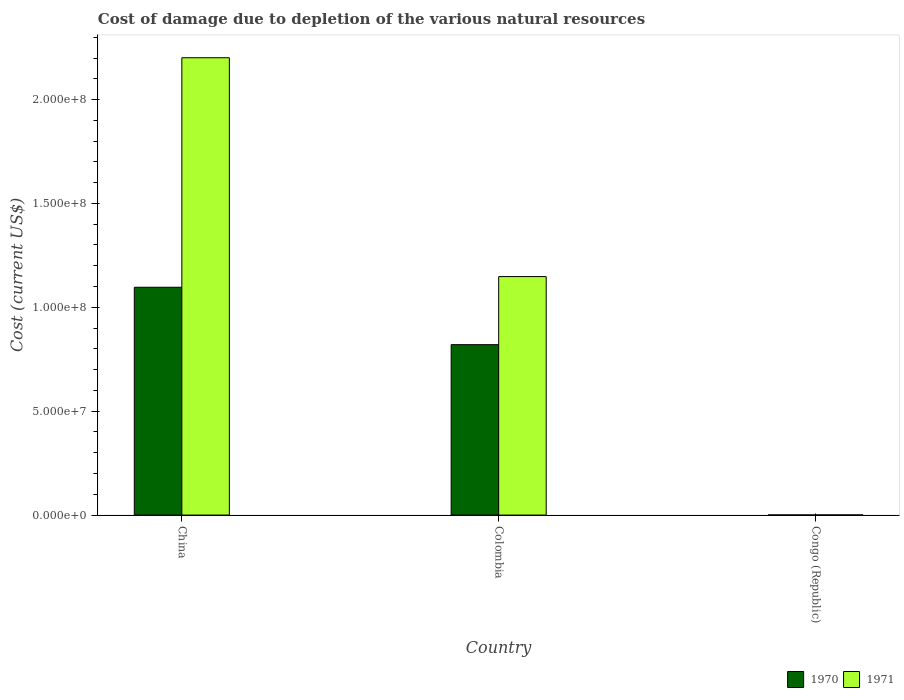How many different coloured bars are there?
Your answer should be very brief. 2. How many groups of bars are there?
Make the answer very short. 3. Are the number of bars on each tick of the X-axis equal?
Your answer should be very brief. Yes. What is the label of the 2nd group of bars from the left?
Ensure brevity in your answer.  Colombia. In how many cases, is the number of bars for a given country not equal to the number of legend labels?
Ensure brevity in your answer.  0. What is the cost of damage caused due to the depletion of various natural resources in 1970 in Congo (Republic)?
Your answer should be very brief. 6.34e+04. Across all countries, what is the maximum cost of damage caused due to the depletion of various natural resources in 1970?
Make the answer very short. 1.10e+08. Across all countries, what is the minimum cost of damage caused due to the depletion of various natural resources in 1970?
Your answer should be very brief. 6.34e+04. In which country was the cost of damage caused due to the depletion of various natural resources in 1971 maximum?
Provide a succinct answer. China. In which country was the cost of damage caused due to the depletion of various natural resources in 1970 minimum?
Provide a short and direct response. Congo (Republic). What is the total cost of damage caused due to the depletion of various natural resources in 1970 in the graph?
Your response must be concise. 1.92e+08. What is the difference between the cost of damage caused due to the depletion of various natural resources in 1970 in Colombia and that in Congo (Republic)?
Give a very brief answer. 8.20e+07. What is the difference between the cost of damage caused due to the depletion of various natural resources in 1971 in Congo (Republic) and the cost of damage caused due to the depletion of various natural resources in 1970 in Colombia?
Offer a very short reply. -8.19e+07. What is the average cost of damage caused due to the depletion of various natural resources in 1970 per country?
Offer a terse response. 6.39e+07. What is the difference between the cost of damage caused due to the depletion of various natural resources of/in 1971 and cost of damage caused due to the depletion of various natural resources of/in 1970 in Congo (Republic)?
Provide a succinct answer. 1.00e+04. What is the ratio of the cost of damage caused due to the depletion of various natural resources in 1970 in China to that in Colombia?
Make the answer very short. 1.34. Is the cost of damage caused due to the depletion of various natural resources in 1971 in Colombia less than that in Congo (Republic)?
Keep it short and to the point. No. What is the difference between the highest and the second highest cost of damage caused due to the depletion of various natural resources in 1970?
Your response must be concise. -1.10e+08. What is the difference between the highest and the lowest cost of damage caused due to the depletion of various natural resources in 1971?
Keep it short and to the point. 2.20e+08. What does the 1st bar from the left in China represents?
Your response must be concise. 1970. How many bars are there?
Ensure brevity in your answer.  6. Are all the bars in the graph horizontal?
Provide a succinct answer. No. How many countries are there in the graph?
Provide a succinct answer. 3. Are the values on the major ticks of Y-axis written in scientific E-notation?
Your answer should be compact. Yes. Where does the legend appear in the graph?
Offer a terse response. Bottom right. What is the title of the graph?
Your answer should be compact. Cost of damage due to depletion of the various natural resources. Does "1972" appear as one of the legend labels in the graph?
Make the answer very short. No. What is the label or title of the Y-axis?
Provide a short and direct response. Cost (current US$). What is the Cost (current US$) of 1970 in China?
Offer a terse response. 1.10e+08. What is the Cost (current US$) of 1971 in China?
Provide a short and direct response. 2.20e+08. What is the Cost (current US$) in 1970 in Colombia?
Your response must be concise. 8.20e+07. What is the Cost (current US$) in 1971 in Colombia?
Offer a very short reply. 1.15e+08. What is the Cost (current US$) in 1970 in Congo (Republic)?
Provide a short and direct response. 6.34e+04. What is the Cost (current US$) in 1971 in Congo (Republic)?
Keep it short and to the point. 7.34e+04. Across all countries, what is the maximum Cost (current US$) of 1970?
Offer a terse response. 1.10e+08. Across all countries, what is the maximum Cost (current US$) in 1971?
Your answer should be very brief. 2.20e+08. Across all countries, what is the minimum Cost (current US$) of 1970?
Provide a short and direct response. 6.34e+04. Across all countries, what is the minimum Cost (current US$) in 1971?
Ensure brevity in your answer.  7.34e+04. What is the total Cost (current US$) of 1970 in the graph?
Provide a succinct answer. 1.92e+08. What is the total Cost (current US$) in 1971 in the graph?
Your answer should be very brief. 3.35e+08. What is the difference between the Cost (current US$) in 1970 in China and that in Colombia?
Your response must be concise. 2.76e+07. What is the difference between the Cost (current US$) in 1971 in China and that in Colombia?
Your answer should be very brief. 1.05e+08. What is the difference between the Cost (current US$) of 1970 in China and that in Congo (Republic)?
Your answer should be very brief. 1.10e+08. What is the difference between the Cost (current US$) in 1971 in China and that in Congo (Republic)?
Make the answer very short. 2.20e+08. What is the difference between the Cost (current US$) in 1970 in Colombia and that in Congo (Republic)?
Make the answer very short. 8.20e+07. What is the difference between the Cost (current US$) in 1971 in Colombia and that in Congo (Republic)?
Offer a very short reply. 1.15e+08. What is the difference between the Cost (current US$) of 1970 in China and the Cost (current US$) of 1971 in Colombia?
Provide a short and direct response. -5.13e+06. What is the difference between the Cost (current US$) in 1970 in China and the Cost (current US$) in 1971 in Congo (Republic)?
Your answer should be very brief. 1.10e+08. What is the difference between the Cost (current US$) in 1970 in Colombia and the Cost (current US$) in 1971 in Congo (Republic)?
Provide a short and direct response. 8.19e+07. What is the average Cost (current US$) of 1970 per country?
Ensure brevity in your answer.  6.39e+07. What is the average Cost (current US$) in 1971 per country?
Your answer should be compact. 1.12e+08. What is the difference between the Cost (current US$) in 1970 and Cost (current US$) in 1971 in China?
Offer a terse response. -1.10e+08. What is the difference between the Cost (current US$) of 1970 and Cost (current US$) of 1971 in Colombia?
Your answer should be very brief. -3.28e+07. What is the difference between the Cost (current US$) in 1970 and Cost (current US$) in 1971 in Congo (Republic)?
Your answer should be very brief. -1.00e+04. What is the ratio of the Cost (current US$) of 1970 in China to that in Colombia?
Ensure brevity in your answer.  1.34. What is the ratio of the Cost (current US$) of 1971 in China to that in Colombia?
Your answer should be very brief. 1.92. What is the ratio of the Cost (current US$) of 1970 in China to that in Congo (Republic)?
Give a very brief answer. 1728.88. What is the ratio of the Cost (current US$) of 1971 in China to that in Congo (Republic)?
Ensure brevity in your answer.  2997.27. What is the ratio of the Cost (current US$) of 1970 in Colombia to that in Congo (Republic)?
Your answer should be compact. 1293.18. What is the ratio of the Cost (current US$) in 1971 in Colombia to that in Congo (Republic)?
Offer a terse response. 1562.98. What is the difference between the highest and the second highest Cost (current US$) in 1970?
Your answer should be very brief. 2.76e+07. What is the difference between the highest and the second highest Cost (current US$) in 1971?
Provide a short and direct response. 1.05e+08. What is the difference between the highest and the lowest Cost (current US$) in 1970?
Ensure brevity in your answer.  1.10e+08. What is the difference between the highest and the lowest Cost (current US$) in 1971?
Your answer should be compact. 2.20e+08. 